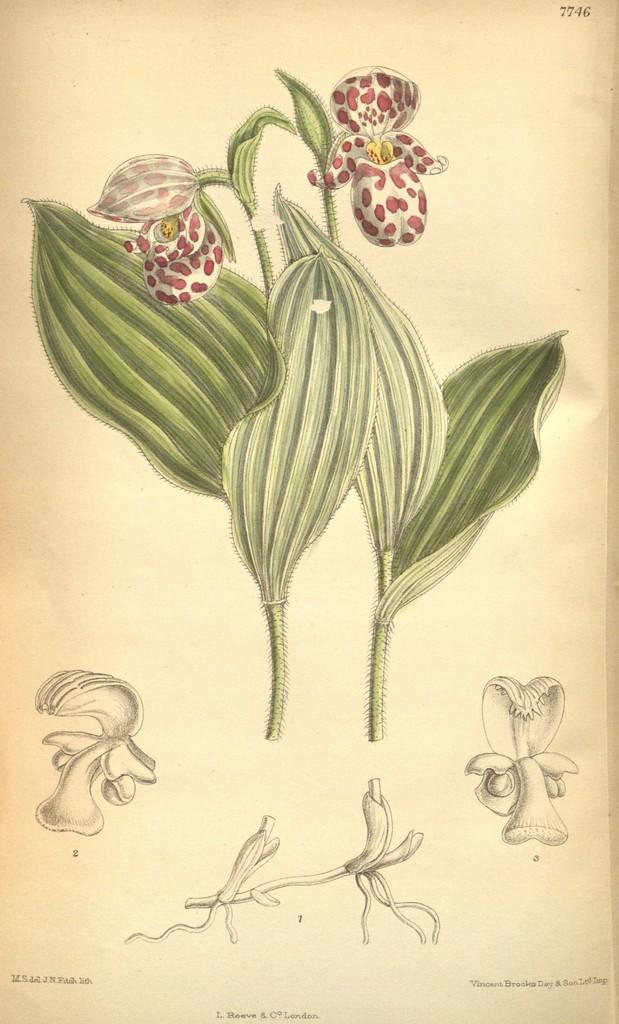Could you give a brief overview of what you see in this image? In this we can able to see a drawing of two plants, there are white flowers with red dots on it. 